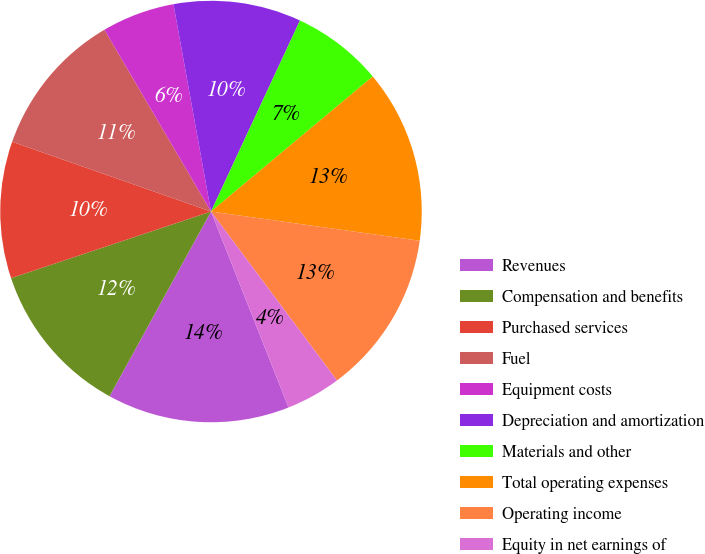Convert chart to OTSL. <chart><loc_0><loc_0><loc_500><loc_500><pie_chart><fcel>Revenues<fcel>Compensation and benefits<fcel>Purchased services<fcel>Fuel<fcel>Equipment costs<fcel>Depreciation and amortization<fcel>Materials and other<fcel>Total operating expenses<fcel>Operating income<fcel>Equity in net earnings of<nl><fcel>13.99%<fcel>11.89%<fcel>10.49%<fcel>11.19%<fcel>5.59%<fcel>9.79%<fcel>6.99%<fcel>13.29%<fcel>12.59%<fcel>4.2%<nl></chart> 